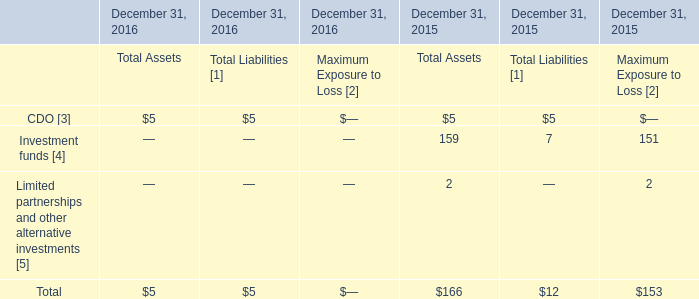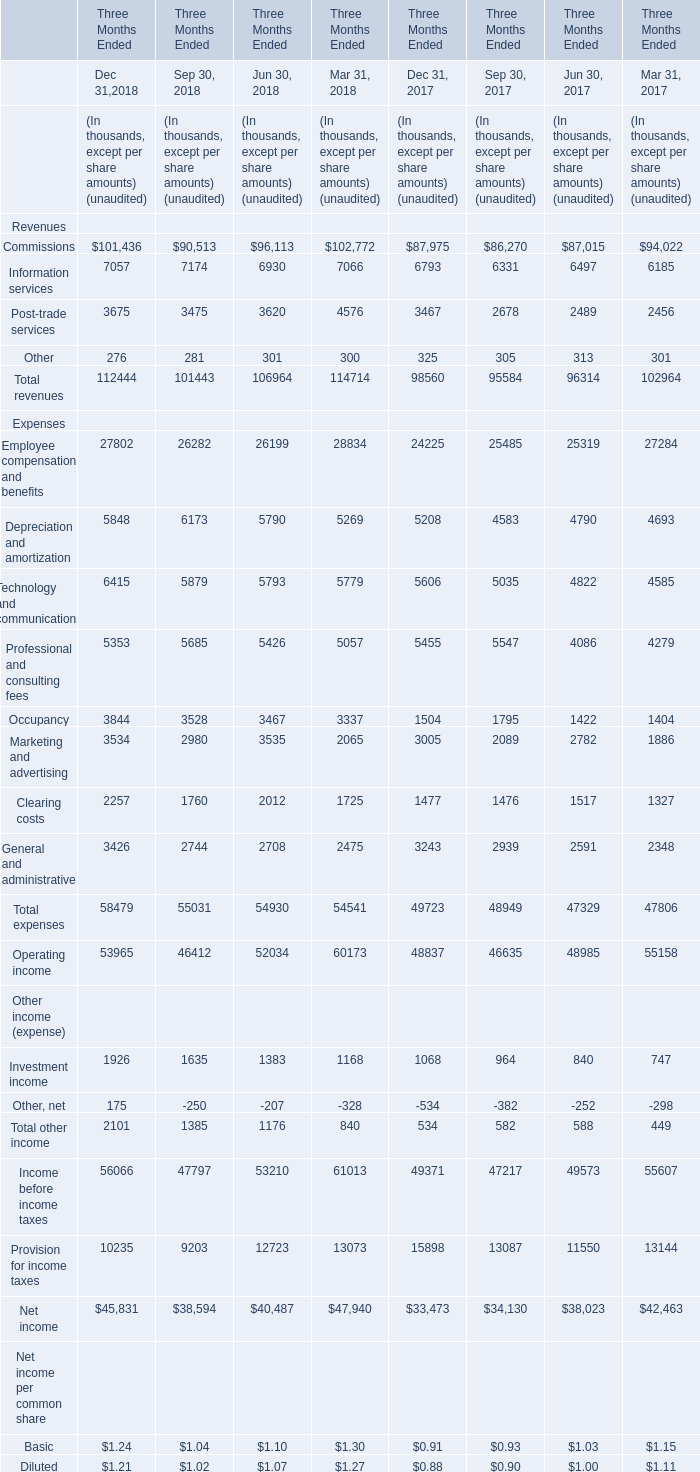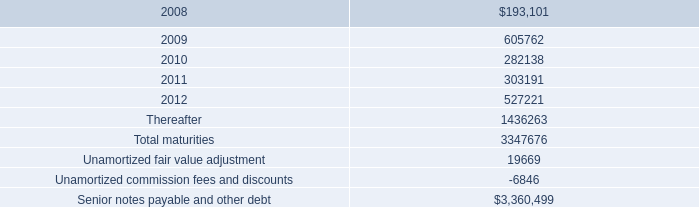What is the difference between the greatest Dec 31 in 2018 and 2017？ (in thousand) 
Computations: (101436 - 87975)
Answer: 13461.0. 